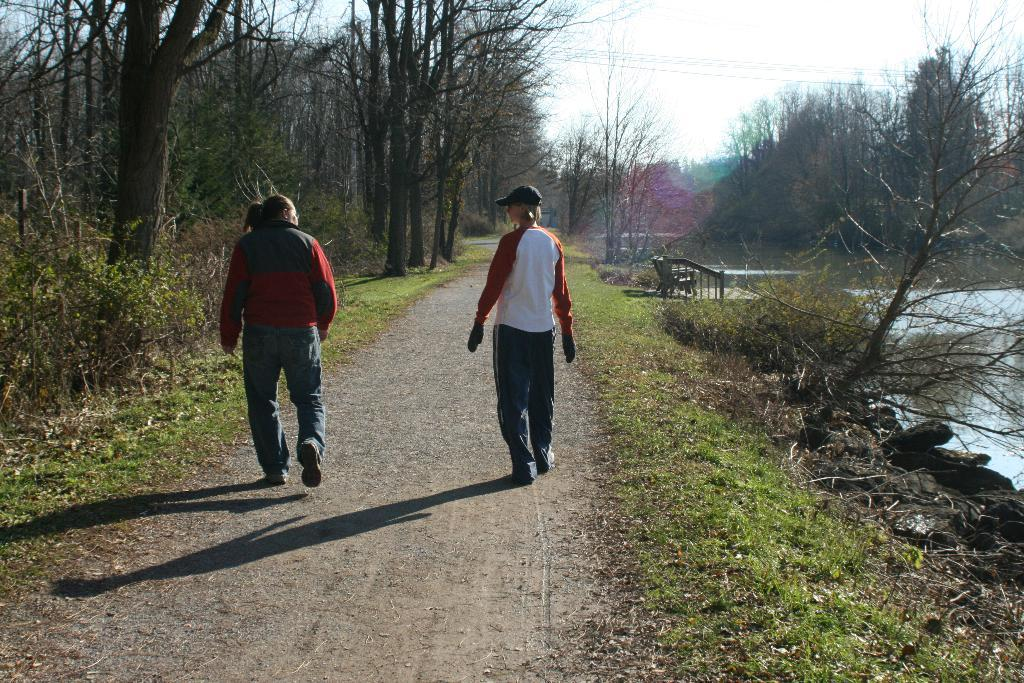How many people are in the image? There are two persons in the image. What are the persons doing in the image? The persons are walking in the image. What can be seen on either side of the path in the image? There are trees and greenery ground on either side of the path in the image. Where is the water located in the image? The water is in the right corner of the image. What letters are the persons carrying in the image? There are no letters visible in the image; the persons are simply walking. How does the digestion process of the trees on either side of the path affect the image? There are no trees with digestion processes in the image; trees do not have digestive systems like animals. 